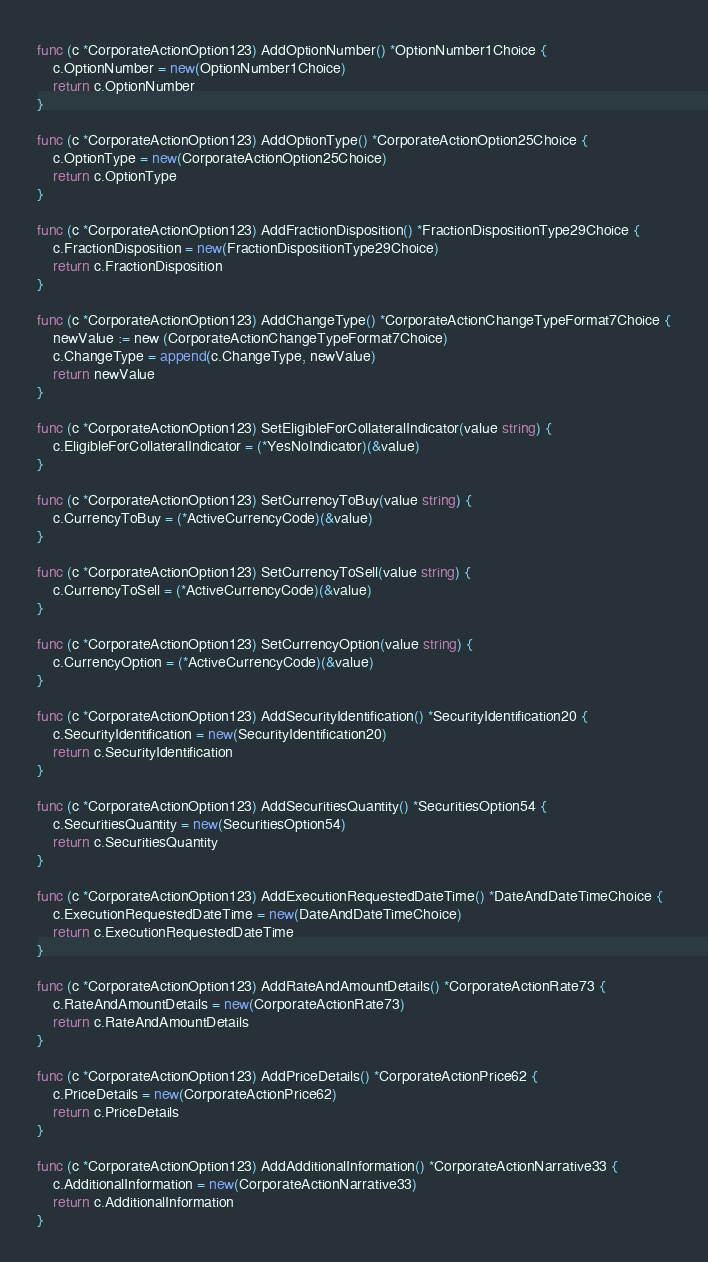Convert code to text. <code><loc_0><loc_0><loc_500><loc_500><_Go_>
func (c *CorporateActionOption123) AddOptionNumber() *OptionNumber1Choice {
	c.OptionNumber = new(OptionNumber1Choice)
	return c.OptionNumber
}

func (c *CorporateActionOption123) AddOptionType() *CorporateActionOption25Choice {
	c.OptionType = new(CorporateActionOption25Choice)
	return c.OptionType
}

func (c *CorporateActionOption123) AddFractionDisposition() *FractionDispositionType29Choice {
	c.FractionDisposition = new(FractionDispositionType29Choice)
	return c.FractionDisposition
}

func (c *CorporateActionOption123) AddChangeType() *CorporateActionChangeTypeFormat7Choice {
	newValue := new (CorporateActionChangeTypeFormat7Choice)
	c.ChangeType = append(c.ChangeType, newValue)
	return newValue
}

func (c *CorporateActionOption123) SetEligibleForCollateralIndicator(value string) {
	c.EligibleForCollateralIndicator = (*YesNoIndicator)(&value)
}

func (c *CorporateActionOption123) SetCurrencyToBuy(value string) {
	c.CurrencyToBuy = (*ActiveCurrencyCode)(&value)
}

func (c *CorporateActionOption123) SetCurrencyToSell(value string) {
	c.CurrencyToSell = (*ActiveCurrencyCode)(&value)
}

func (c *CorporateActionOption123) SetCurrencyOption(value string) {
	c.CurrencyOption = (*ActiveCurrencyCode)(&value)
}

func (c *CorporateActionOption123) AddSecurityIdentification() *SecurityIdentification20 {
	c.SecurityIdentification = new(SecurityIdentification20)
	return c.SecurityIdentification
}

func (c *CorporateActionOption123) AddSecuritiesQuantity() *SecuritiesOption54 {
	c.SecuritiesQuantity = new(SecuritiesOption54)
	return c.SecuritiesQuantity
}

func (c *CorporateActionOption123) AddExecutionRequestedDateTime() *DateAndDateTimeChoice {
	c.ExecutionRequestedDateTime = new(DateAndDateTimeChoice)
	return c.ExecutionRequestedDateTime
}

func (c *CorporateActionOption123) AddRateAndAmountDetails() *CorporateActionRate73 {
	c.RateAndAmountDetails = new(CorporateActionRate73)
	return c.RateAndAmountDetails
}

func (c *CorporateActionOption123) AddPriceDetails() *CorporateActionPrice62 {
	c.PriceDetails = new(CorporateActionPrice62)
	return c.PriceDetails
}

func (c *CorporateActionOption123) AddAdditionalInformation() *CorporateActionNarrative33 {
	c.AdditionalInformation = new(CorporateActionNarrative33)
	return c.AdditionalInformation
}

</code> 